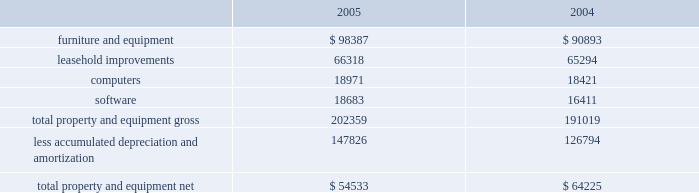Value , which may be maturity , the company does not consider these investments to be other-than-temporarily impaired as of december 31 , 2005 and 2004 .
Gross realized gains and losses for 2005 were $ 15000 and $ 75000 , respectively .
Gross realized gains and losses for 2004 were $ 628000 and $ 205000 , respectively .
Gross realized gains for 2003 were $ 1249000 .
There were no gross realized losses for 2003 .
Maturities stated are effective maturities .
Restricted cash at december 31 , 2005 and 2004 , the company held $ 41482000 and $ 49847000 , respectively , in restricted cash .
At december 31 , 2005 and 2004 the balance was held in deposit with certain banks predominantly to collateralize conditional stand-by letters of credit in the names of the company's landlords pursuant to certain operating lease agreements .
Property and equipment property and equipment consist of the following at december 31 ( in thousands ) : depreciation expense for the years ended december 31 , 2005 , 2004 and 2003 was $ 26307000 , $ 28353000 and $ 27988000 respectively .
In 2005 and 2004 , the company wrote off certain assets that were fully depreciated and no longer utilized .
There was no effect on the company's net property and equipment .
Additionally , the company wrote off or sold certain assets that were not fully depreciated .
The net loss on disposal of those assets was $ 344000 for 2005 and $ 43000 for 2004 .
Investments in accordance with the company's policy , as outlined in note b , "accounting policies" the company assessed its investment in altus pharmaceuticals , inc .
( "altus" ) , which it accounts for using the cost method , and determined that there had not been any adjustments to the fair values of that investment which would indicate a decrease in its fair value below the carrying value that would require the company to write down the investment basis of the asset , as of december 31 , 2005 and december 31 , 2004 .
The company's cost basis carrying value in its outstanding equity and warrants of altus was $ 18863000 at december 31 , 2005 and 2004. .

What is the percent change in net loss on disposal of assets between 2004 and 2005? 
Computations: ((344000 - 43000) / 43000)
Answer: 7.0. Value , which may be maturity , the company does not consider these investments to be other-than-temporarily impaired as of december 31 , 2005 and 2004 .
Gross realized gains and losses for 2005 were $ 15000 and $ 75000 , respectively .
Gross realized gains and losses for 2004 were $ 628000 and $ 205000 , respectively .
Gross realized gains for 2003 were $ 1249000 .
There were no gross realized losses for 2003 .
Maturities stated are effective maturities .
Restricted cash at december 31 , 2005 and 2004 , the company held $ 41482000 and $ 49847000 , respectively , in restricted cash .
At december 31 , 2005 and 2004 the balance was held in deposit with certain banks predominantly to collateralize conditional stand-by letters of credit in the names of the company's landlords pursuant to certain operating lease agreements .
Property and equipment property and equipment consist of the following at december 31 ( in thousands ) : depreciation expense for the years ended december 31 , 2005 , 2004 and 2003 was $ 26307000 , $ 28353000 and $ 27988000 respectively .
In 2005 and 2004 , the company wrote off certain assets that were fully depreciated and no longer utilized .
There was no effect on the company's net property and equipment .
Additionally , the company wrote off or sold certain assets that were not fully depreciated .
The net loss on disposal of those assets was $ 344000 for 2005 and $ 43000 for 2004 .
Investments in accordance with the company's policy , as outlined in note b , "accounting policies" the company assessed its investment in altus pharmaceuticals , inc .
( "altus" ) , which it accounts for using the cost method , and determined that there had not been any adjustments to the fair values of that investment which would indicate a decrease in its fair value below the carrying value that would require the company to write down the investment basis of the asset , as of december 31 , 2005 and december 31 , 2004 .
The company's cost basis carrying value in its outstanding equity and warrants of altus was $ 18863000 at december 31 , 2005 and 2004. .

What percent of the 2005 gross total property and equipment value is related to software? 
Computations: (18683 / 54533)
Answer: 0.3426. Value , which may be maturity , the company does not consider these investments to be other-than-temporarily impaired as of december 31 , 2005 and 2004 .
Gross realized gains and losses for 2005 were $ 15000 and $ 75000 , respectively .
Gross realized gains and losses for 2004 were $ 628000 and $ 205000 , respectively .
Gross realized gains for 2003 were $ 1249000 .
There were no gross realized losses for 2003 .
Maturities stated are effective maturities .
Restricted cash at december 31 , 2005 and 2004 , the company held $ 41482000 and $ 49847000 , respectively , in restricted cash .
At december 31 , 2005 and 2004 the balance was held in deposit with certain banks predominantly to collateralize conditional stand-by letters of credit in the names of the company's landlords pursuant to certain operating lease agreements .
Property and equipment property and equipment consist of the following at december 31 ( in thousands ) : depreciation expense for the years ended december 31 , 2005 , 2004 and 2003 was $ 26307000 , $ 28353000 and $ 27988000 respectively .
In 2005 and 2004 , the company wrote off certain assets that were fully depreciated and no longer utilized .
There was no effect on the company's net property and equipment .
Additionally , the company wrote off or sold certain assets that were not fully depreciated .
The net loss on disposal of those assets was $ 344000 for 2005 and $ 43000 for 2004 .
Investments in accordance with the company's policy , as outlined in note b , "accounting policies" the company assessed its investment in altus pharmaceuticals , inc .
( "altus" ) , which it accounts for using the cost method , and determined that there had not been any adjustments to the fair values of that investment which would indicate a decrease in its fair value below the carrying value that would require the company to write down the investment basis of the asset , as of december 31 , 2005 and december 31 , 2004 .
The company's cost basis carrying value in its outstanding equity and warrants of altus was $ 18863000 at december 31 , 2005 and 2004. .

What was the ratio of the net loss on the disposal of the unfully depreciated assets in 2005 compared 2004? 
Computations: (344000 / 43000)
Answer: 8.0. 